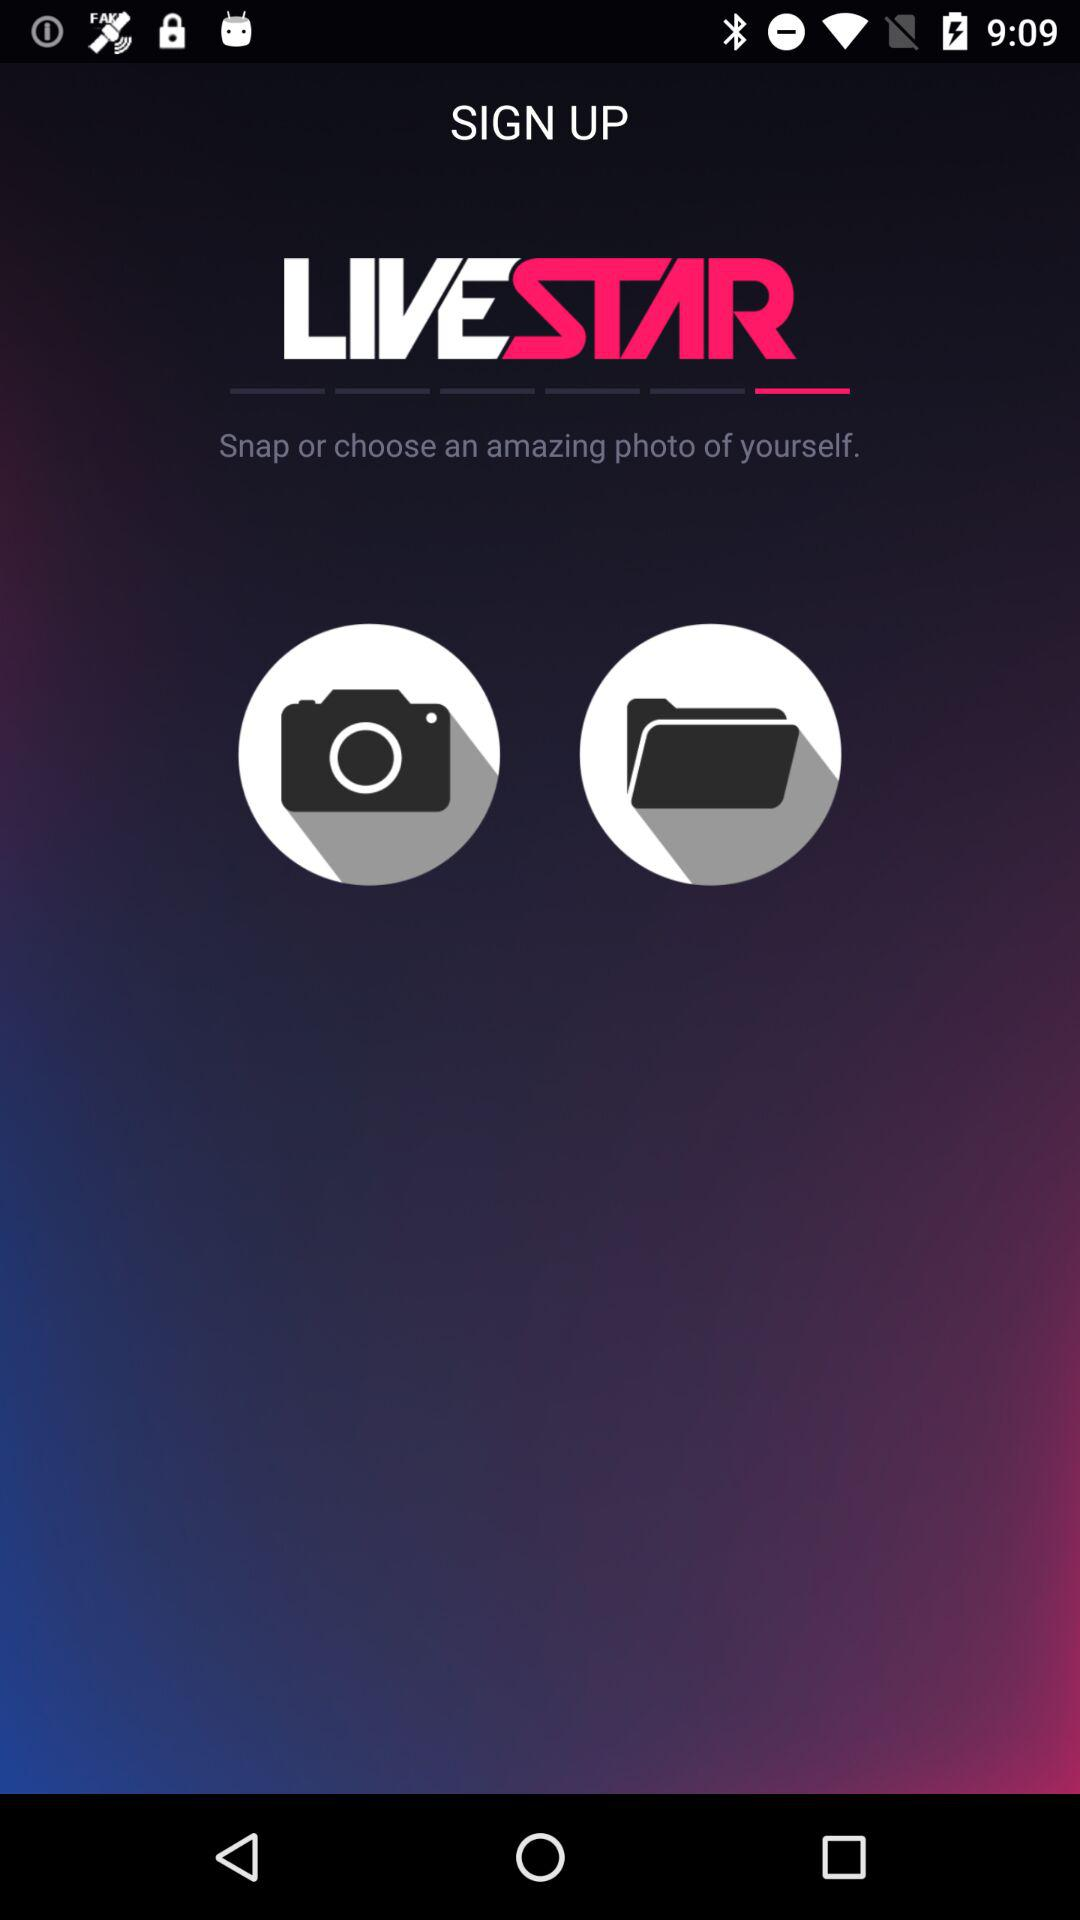What is the application name? The application name is "LIVESTAR". 